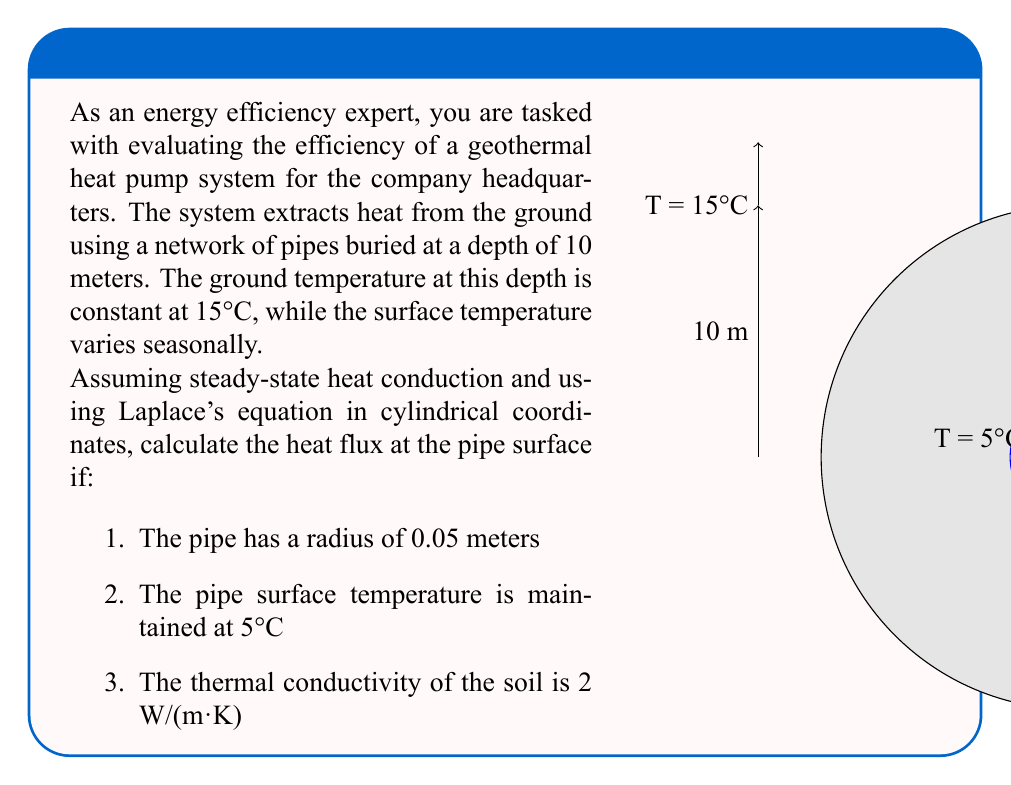Teach me how to tackle this problem. To solve this problem, we'll use Laplace's equation in cylindrical coordinates and apply the given boundary conditions. Here's a step-by-step approach:

1) Laplace's equation in cylindrical coordinates for a radially symmetric problem is:

   $$\frac{1}{r} \frac{d}{dr} \left(r \frac{dT}{dr}\right) = 0$$

2) Integrating once with respect to r:

   $$r \frac{dT}{dr} = C_1$$

3) Integrating again:

   $$T(r) = C_1 \ln(r) + C_2$$

4) Apply boundary conditions:
   At r = 0.05 m, T = 5°C
   At r = 10 m, T = 15°C

5) Substituting these conditions:

   $$5 = C_1 \ln(0.05) + C_2$$
   $$15 = C_1 \ln(10) + C_2$$

6) Subtracting these equations:

   $$10 = C_1 [\ln(10) - \ln(0.05)]$$
   $$10 = C_1 \ln(200)$$
   $$C_1 = \frac{10}{\ln(200)} \approx 1.9235$$

7) Substituting back to find $C_2$:

   $$5 = 1.9235 \ln(0.05) + C_2$$
   $$C_2 \approx 11.0478$$

8) Now we have the temperature distribution:

   $$T(r) = 1.9235 \ln(r) + 11.0478$$

9) To find the heat flux at the pipe surface, we use Fourier's law:

   $$q = -k \frac{dT}{dr}$$

   where $k$ is the thermal conductivity.

10) Differentiating $T(r)$:

    $$\frac{dT}{dr} = \frac{1.9235}{r}$$

11) At r = 0.05 m:

    $$q = -2 \cdot \frac{1.9235}{0.05} = -76.94 \text{ W/m}^2$$

The negative sign indicates that heat is flowing from the ground into the pipe.
Answer: $-76.94 \text{ W/m}^2$ 